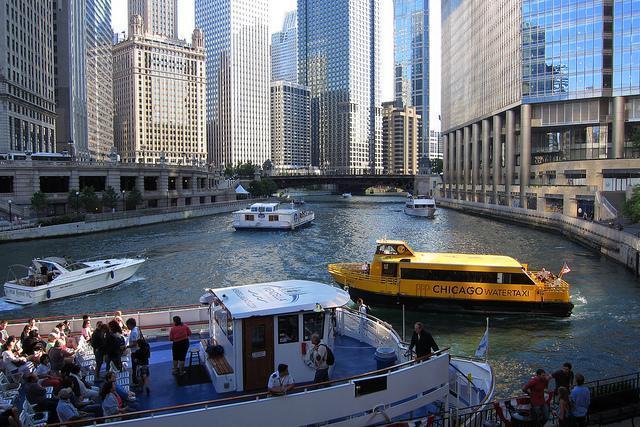How many boats are visible?
Give a very brief answer. 3. 